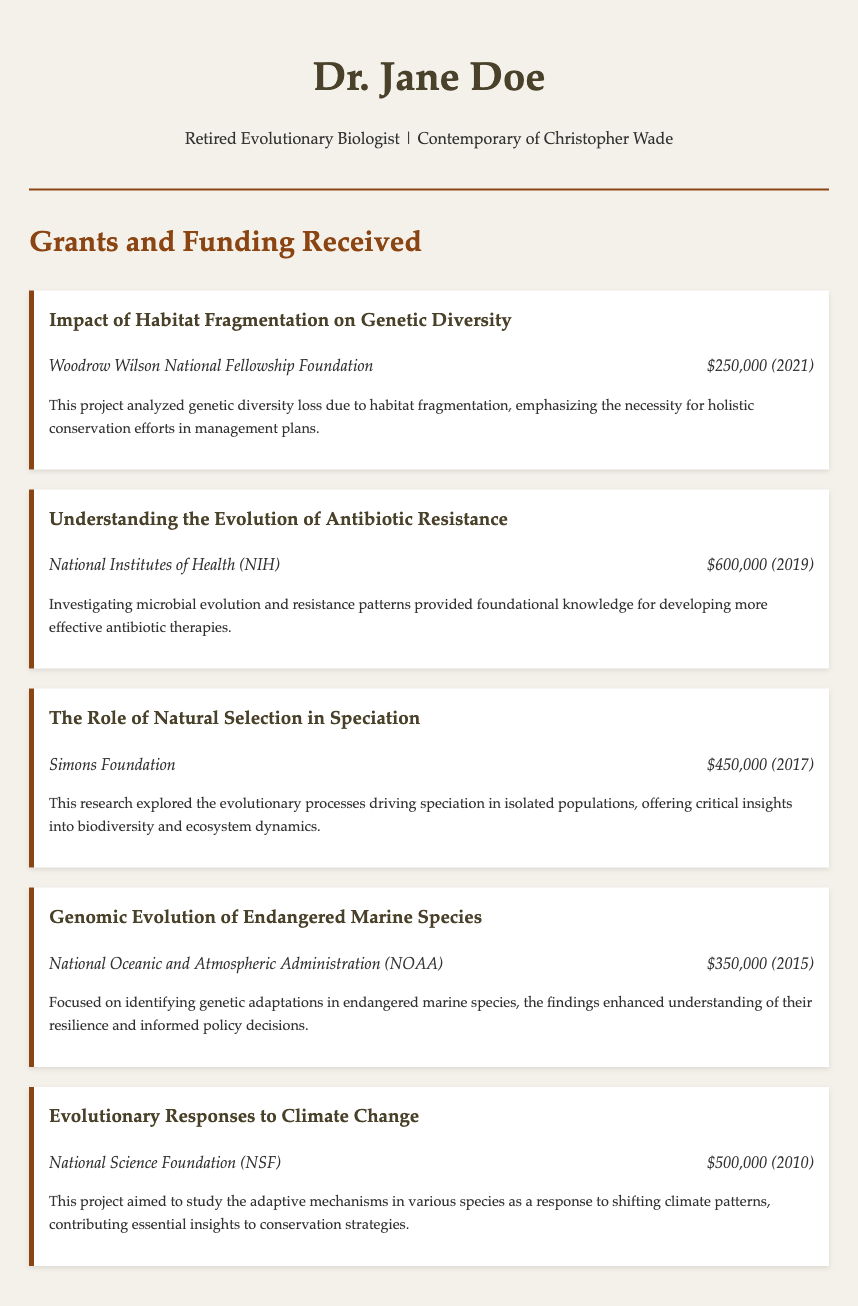What is the title of the most recent grant received? The most recent grant listed in the document is "Impact of Habitat Fragmentation on Genetic Diversity."
Answer: Impact of Habitat Fragmentation on Genetic Diversity What was the amount awarded for the grant from the NIH? The NIH grant was awarded for understanding antibiotic resistance, with the amount specified in the document as $600,000.
Answer: $600,000 Which organization funded the project on natural selection and speciation? The project on the role of natural selection in speciation was funded by the Simons Foundation.
Answer: Simons Foundation In what year was the grant for genomic evolution of endangered marine species awarded? The grant for genomic evolution of endangered marine species was awarded in 2015 as stated in the document.
Answer: 2015 What is the sum of all grant amounts received? The total amount of the grants can be calculated as $250,000 + $600,000 + $450,000 + $350,000 + $500,000 which equals $2,100,000.
Answer: $2,100,000 What overarching theme is present in the majority of the grants listed? The overarching theme evidenced in the grants is the study of evolutionary processes and their implications for conservation.
Answer: Evolutionary processes Which project specifically contributes insights into effective antibiotic therapies? The project titled "Understanding the Evolution of Antibiotic Resistance" aligns with the development of effective antibiotic therapies.
Answer: Understanding the Evolution of Antibiotic Resistance For which grant was the funding amount the lowest? The funding amount for the grant from the Woodrow Wilson National Fellowship Foundation is the lowest at $250,000.
Answer: $250,000 What type of document is this? This document is a Curriculum Vitae, specifically detailing grants and funding received by the individual.
Answer: Curriculum Vitae 